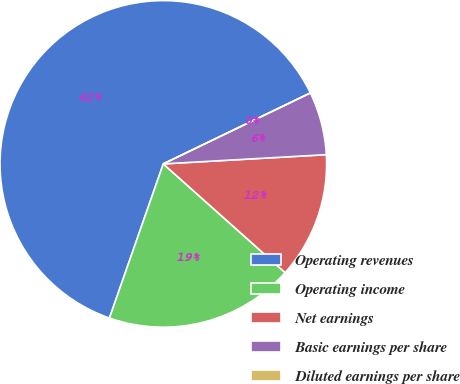<chart> <loc_0><loc_0><loc_500><loc_500><pie_chart><fcel>Operating revenues<fcel>Operating income<fcel>Net earnings<fcel>Basic earnings per share<fcel>Diluted earnings per share<nl><fcel>62.5%<fcel>18.75%<fcel>12.5%<fcel>6.25%<fcel>0.0%<nl></chart> 